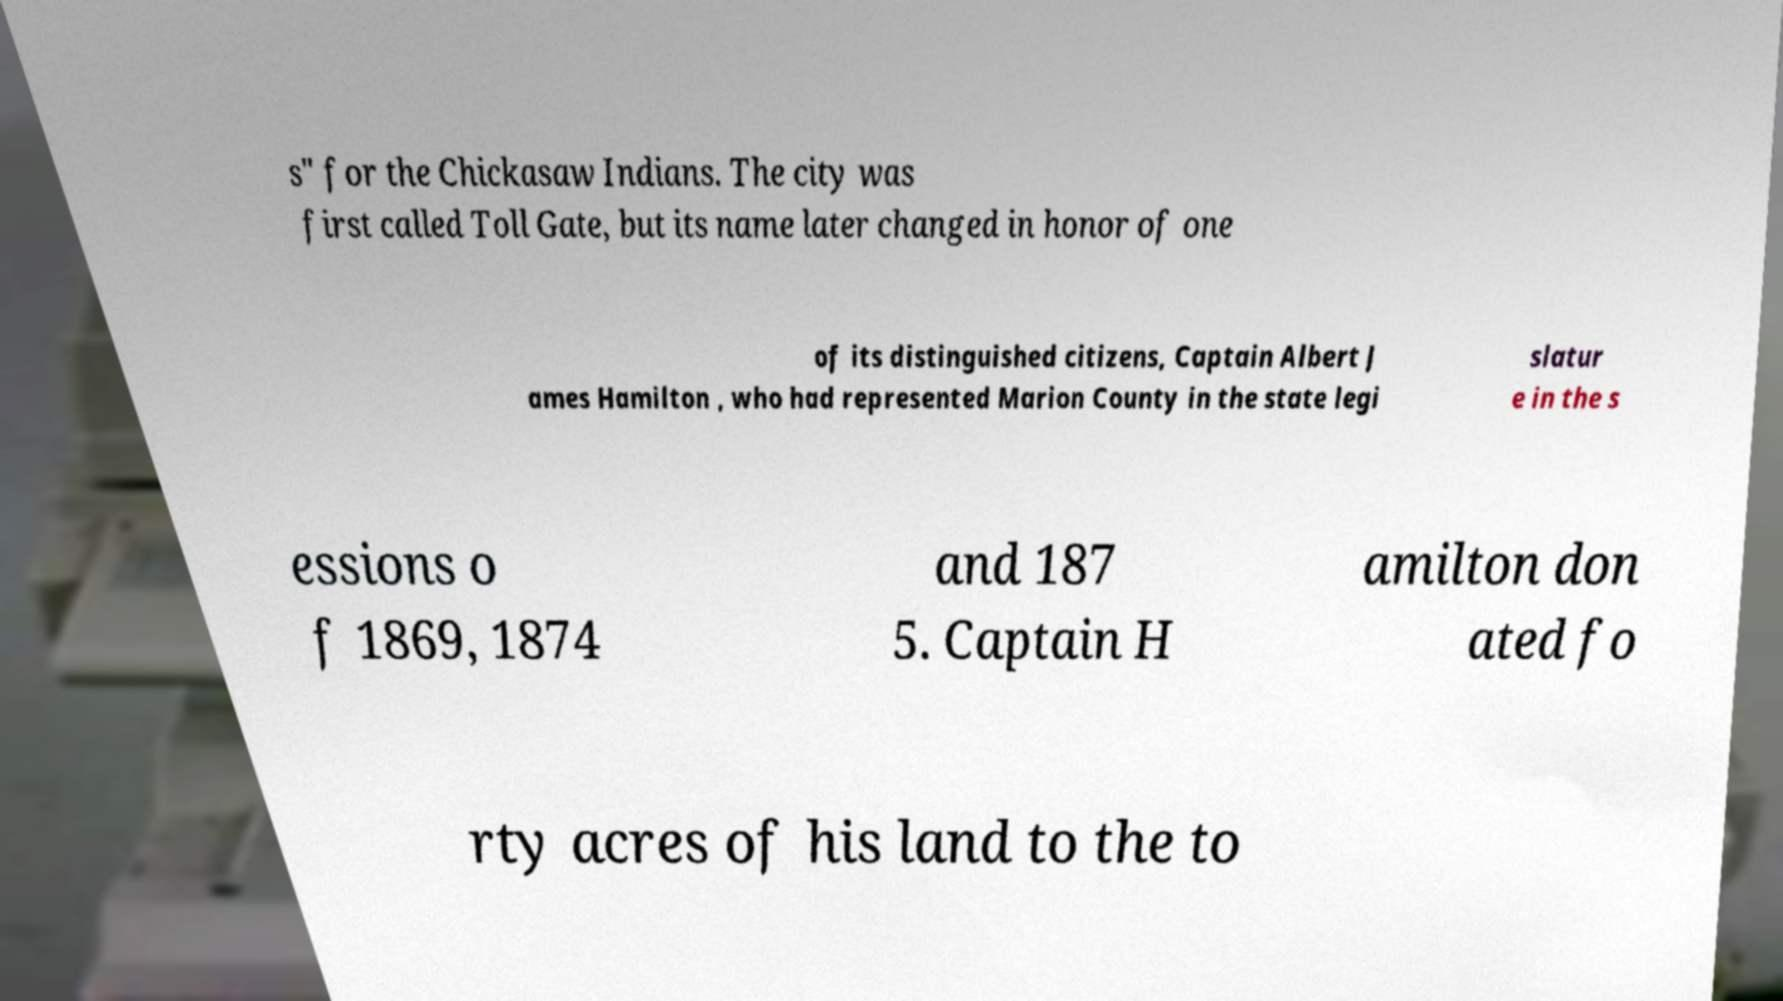Can you accurately transcribe the text from the provided image for me? s" for the Chickasaw Indians. The city was first called Toll Gate, but its name later changed in honor of one of its distinguished citizens, Captain Albert J ames Hamilton , who had represented Marion County in the state legi slatur e in the s essions o f 1869, 1874 and 187 5. Captain H amilton don ated fo rty acres of his land to the to 